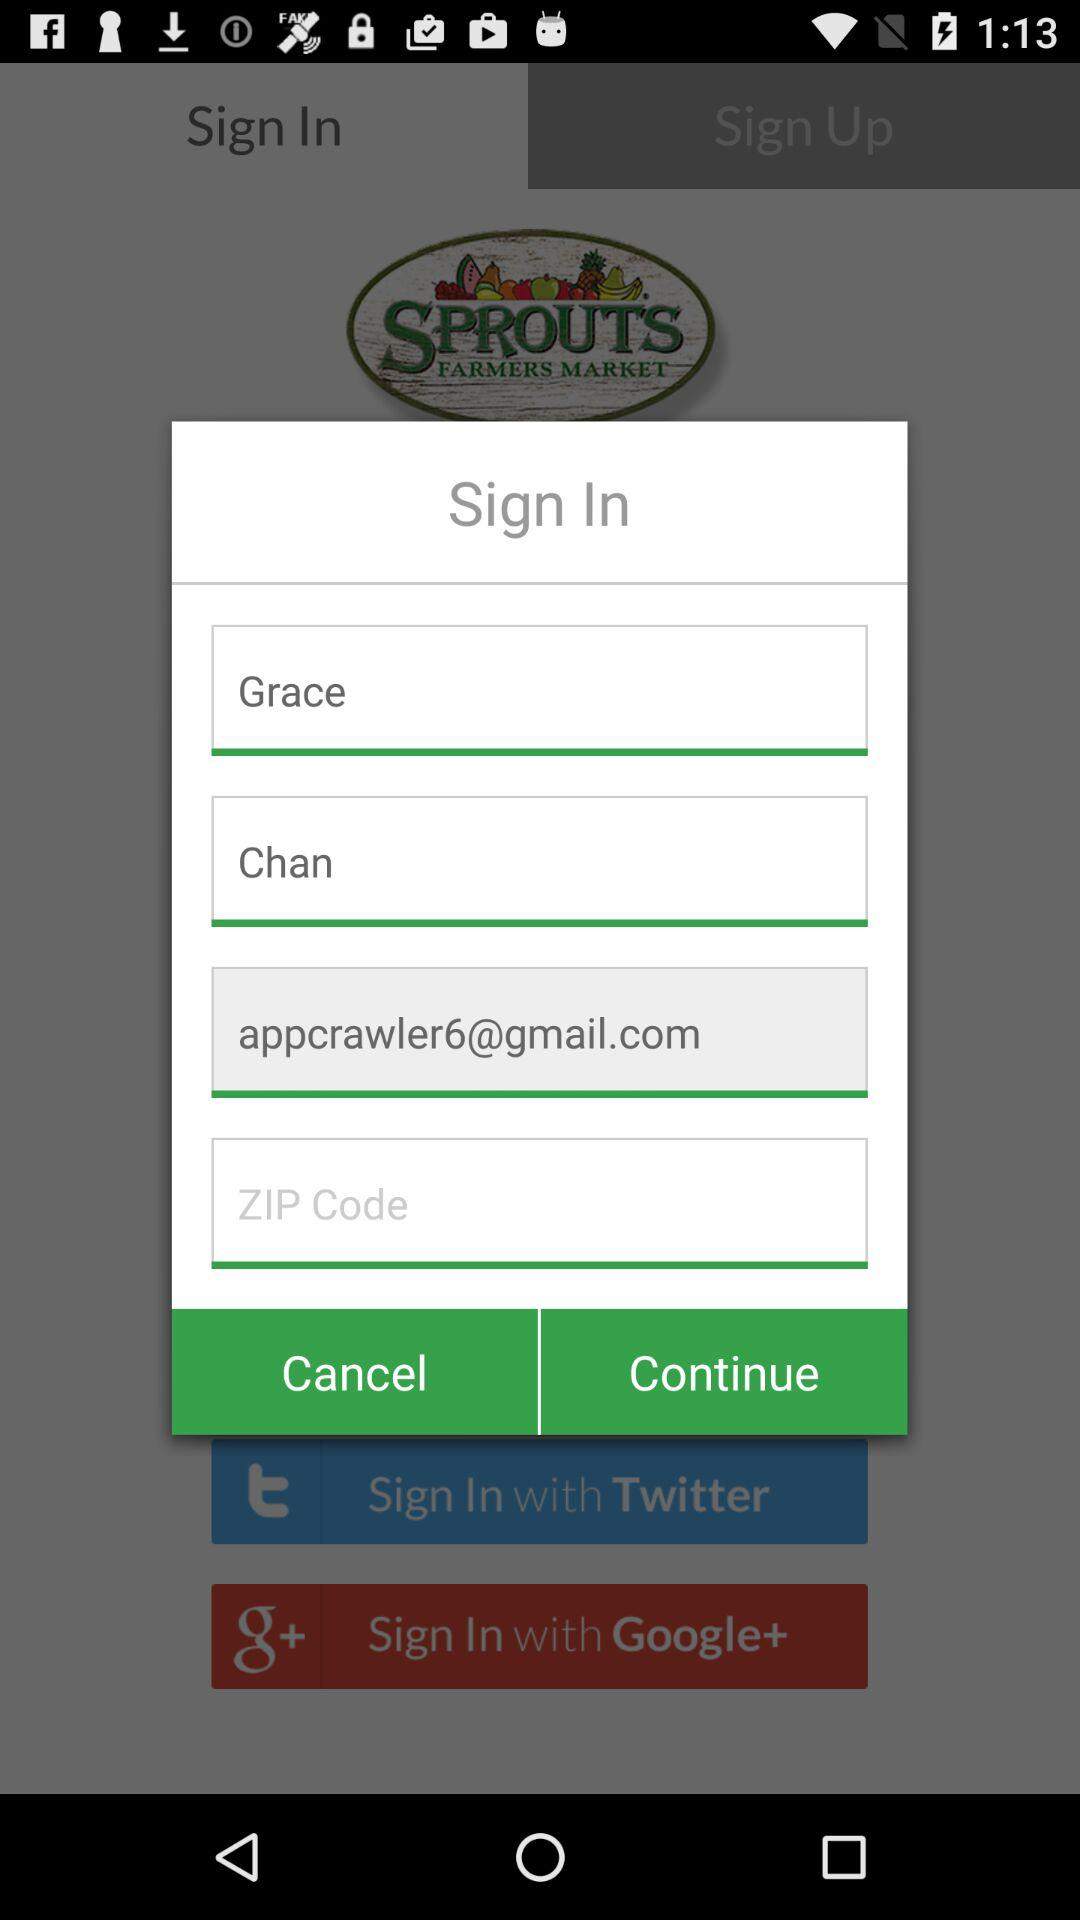How many text inputs are in the form?
Answer the question using a single word or phrase. 4 